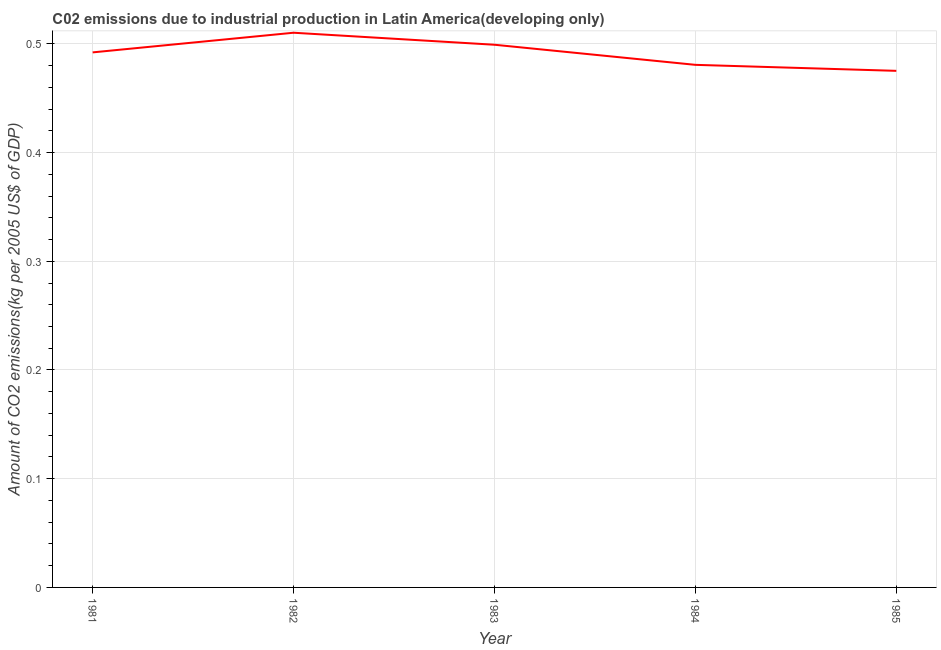What is the amount of co2 emissions in 1981?
Provide a succinct answer. 0.49. Across all years, what is the maximum amount of co2 emissions?
Offer a terse response. 0.51. Across all years, what is the minimum amount of co2 emissions?
Keep it short and to the point. 0.48. In which year was the amount of co2 emissions minimum?
Offer a terse response. 1985. What is the sum of the amount of co2 emissions?
Your response must be concise. 2.46. What is the difference between the amount of co2 emissions in 1981 and 1985?
Provide a short and direct response. 0.02. What is the average amount of co2 emissions per year?
Your answer should be very brief. 0.49. What is the median amount of co2 emissions?
Make the answer very short. 0.49. In how many years, is the amount of co2 emissions greater than 0.28 kg per 2005 US$ of GDP?
Keep it short and to the point. 5. Do a majority of the years between 1981 and 1984 (inclusive) have amount of co2 emissions greater than 0.1 kg per 2005 US$ of GDP?
Keep it short and to the point. Yes. What is the ratio of the amount of co2 emissions in 1981 to that in 1985?
Your answer should be compact. 1.04. Is the amount of co2 emissions in 1982 less than that in 1984?
Your response must be concise. No. Is the difference between the amount of co2 emissions in 1983 and 1984 greater than the difference between any two years?
Your answer should be very brief. No. What is the difference between the highest and the second highest amount of co2 emissions?
Ensure brevity in your answer.  0.01. Is the sum of the amount of co2 emissions in 1981 and 1983 greater than the maximum amount of co2 emissions across all years?
Offer a very short reply. Yes. What is the difference between the highest and the lowest amount of co2 emissions?
Offer a very short reply. 0.04. How many lines are there?
Give a very brief answer. 1. How many years are there in the graph?
Offer a terse response. 5. What is the difference between two consecutive major ticks on the Y-axis?
Offer a very short reply. 0.1. Does the graph contain grids?
Ensure brevity in your answer.  Yes. What is the title of the graph?
Provide a short and direct response. C02 emissions due to industrial production in Latin America(developing only). What is the label or title of the X-axis?
Keep it short and to the point. Year. What is the label or title of the Y-axis?
Make the answer very short. Amount of CO2 emissions(kg per 2005 US$ of GDP). What is the Amount of CO2 emissions(kg per 2005 US$ of GDP) of 1981?
Make the answer very short. 0.49. What is the Amount of CO2 emissions(kg per 2005 US$ of GDP) in 1982?
Offer a terse response. 0.51. What is the Amount of CO2 emissions(kg per 2005 US$ of GDP) of 1983?
Give a very brief answer. 0.5. What is the Amount of CO2 emissions(kg per 2005 US$ of GDP) of 1984?
Keep it short and to the point. 0.48. What is the Amount of CO2 emissions(kg per 2005 US$ of GDP) of 1985?
Offer a terse response. 0.48. What is the difference between the Amount of CO2 emissions(kg per 2005 US$ of GDP) in 1981 and 1982?
Ensure brevity in your answer.  -0.02. What is the difference between the Amount of CO2 emissions(kg per 2005 US$ of GDP) in 1981 and 1983?
Keep it short and to the point. -0.01. What is the difference between the Amount of CO2 emissions(kg per 2005 US$ of GDP) in 1981 and 1984?
Ensure brevity in your answer.  0.01. What is the difference between the Amount of CO2 emissions(kg per 2005 US$ of GDP) in 1981 and 1985?
Provide a succinct answer. 0.02. What is the difference between the Amount of CO2 emissions(kg per 2005 US$ of GDP) in 1982 and 1983?
Provide a short and direct response. 0.01. What is the difference between the Amount of CO2 emissions(kg per 2005 US$ of GDP) in 1982 and 1984?
Make the answer very short. 0.03. What is the difference between the Amount of CO2 emissions(kg per 2005 US$ of GDP) in 1982 and 1985?
Offer a terse response. 0.04. What is the difference between the Amount of CO2 emissions(kg per 2005 US$ of GDP) in 1983 and 1984?
Your response must be concise. 0.02. What is the difference between the Amount of CO2 emissions(kg per 2005 US$ of GDP) in 1983 and 1985?
Offer a very short reply. 0.02. What is the difference between the Amount of CO2 emissions(kg per 2005 US$ of GDP) in 1984 and 1985?
Provide a short and direct response. 0.01. What is the ratio of the Amount of CO2 emissions(kg per 2005 US$ of GDP) in 1981 to that in 1983?
Provide a succinct answer. 0.99. What is the ratio of the Amount of CO2 emissions(kg per 2005 US$ of GDP) in 1981 to that in 1985?
Ensure brevity in your answer.  1.04. What is the ratio of the Amount of CO2 emissions(kg per 2005 US$ of GDP) in 1982 to that in 1984?
Offer a terse response. 1.06. What is the ratio of the Amount of CO2 emissions(kg per 2005 US$ of GDP) in 1982 to that in 1985?
Keep it short and to the point. 1.07. What is the ratio of the Amount of CO2 emissions(kg per 2005 US$ of GDP) in 1983 to that in 1984?
Your answer should be very brief. 1.04. What is the ratio of the Amount of CO2 emissions(kg per 2005 US$ of GDP) in 1983 to that in 1985?
Your response must be concise. 1.05. 